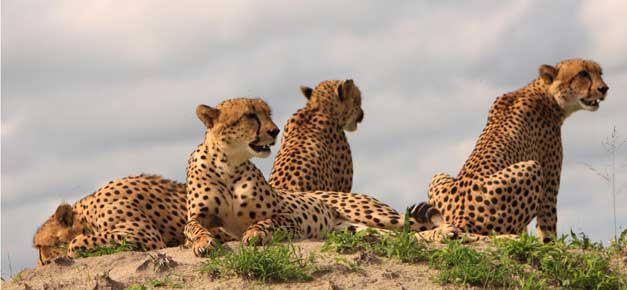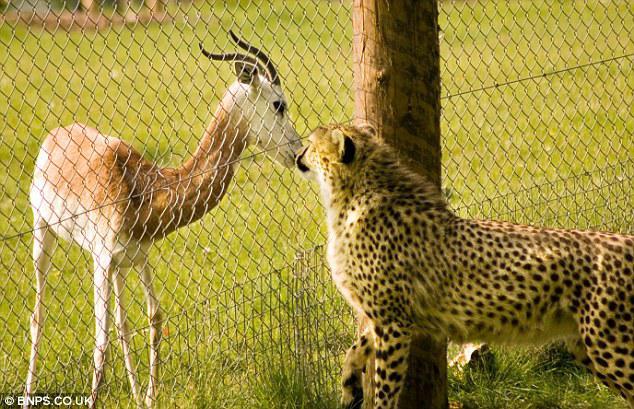The first image is the image on the left, the second image is the image on the right. Examine the images to the left and right. Is the description "there are exactly three animals in the image on the right" accurate? Answer yes or no. No. The first image is the image on the left, the second image is the image on the right. Given the left and right images, does the statement "An image shows at least one cheetah near an animal with curved horns." hold true? Answer yes or no. Yes. 